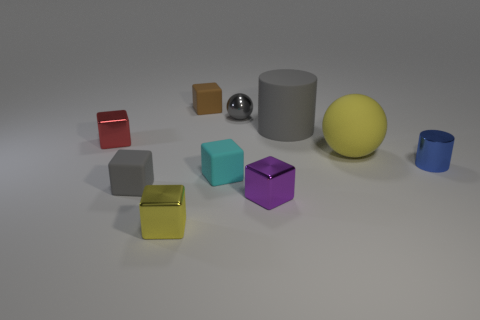Subtract all purple cubes. How many cubes are left? 5 Subtract all small yellow metallic cubes. How many cubes are left? 5 Subtract all yellow blocks. Subtract all blue spheres. How many blocks are left? 5 Subtract all cylinders. How many objects are left? 8 Subtract 0 brown cylinders. How many objects are left? 10 Subtract all tiny blue metallic cylinders. Subtract all small yellow shiny objects. How many objects are left? 8 Add 5 small gray metal spheres. How many small gray metal spheres are left? 6 Add 5 tiny blue metallic cubes. How many tiny blue metallic cubes exist? 5 